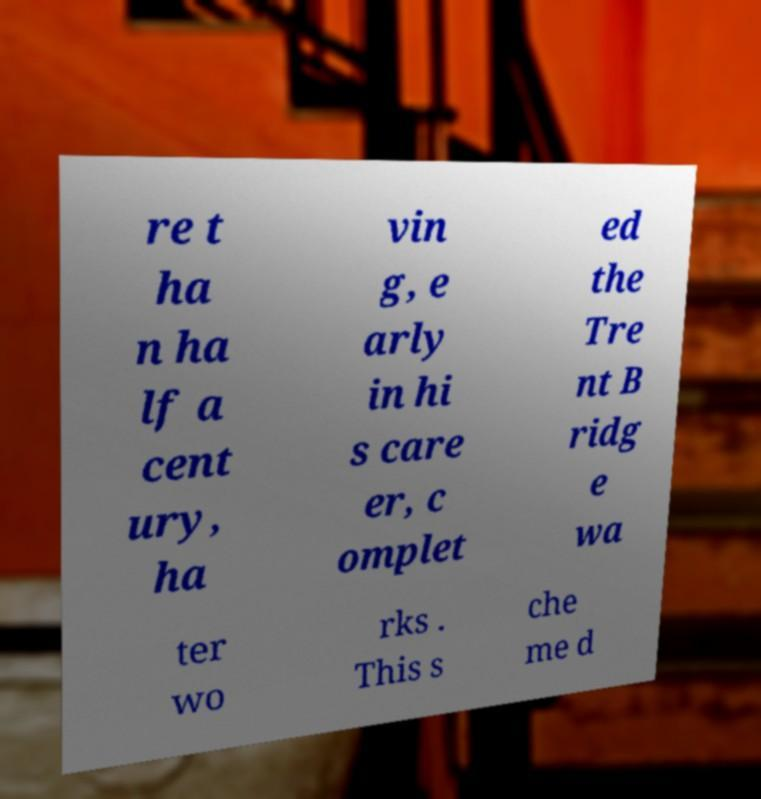For documentation purposes, I need the text within this image transcribed. Could you provide that? re t ha n ha lf a cent ury, ha vin g, e arly in hi s care er, c omplet ed the Tre nt B ridg e wa ter wo rks . This s che me d 